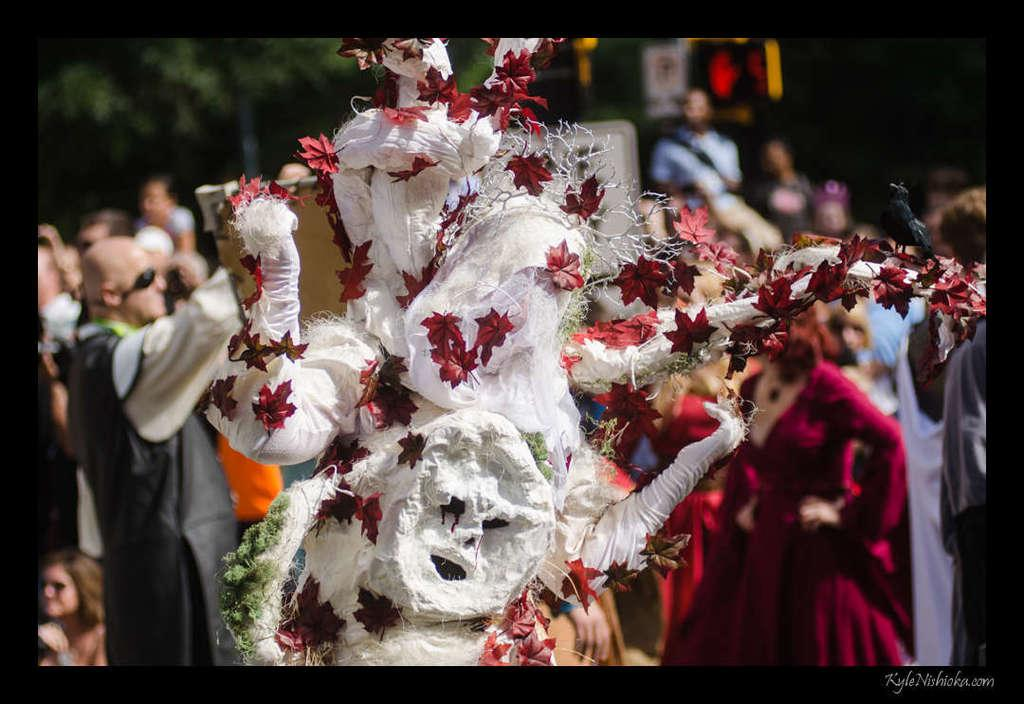What is the person in the foreground of the image wearing? The person is wearing a mask of a tree in the foreground of the image. What can be seen in the background of the image? There are people in the background of the image. What type of vegetation is visible at the top of the image? There are trees at the top of the image. What type of scarf is the tree wearing in the image? There is no tree wearing a scarf in the image; it is a person wearing a mask of a tree. How many heads does the tree have in the image? The tree mask worn by the person in the image has one head, as it is a representation of a tree and not a living being. 